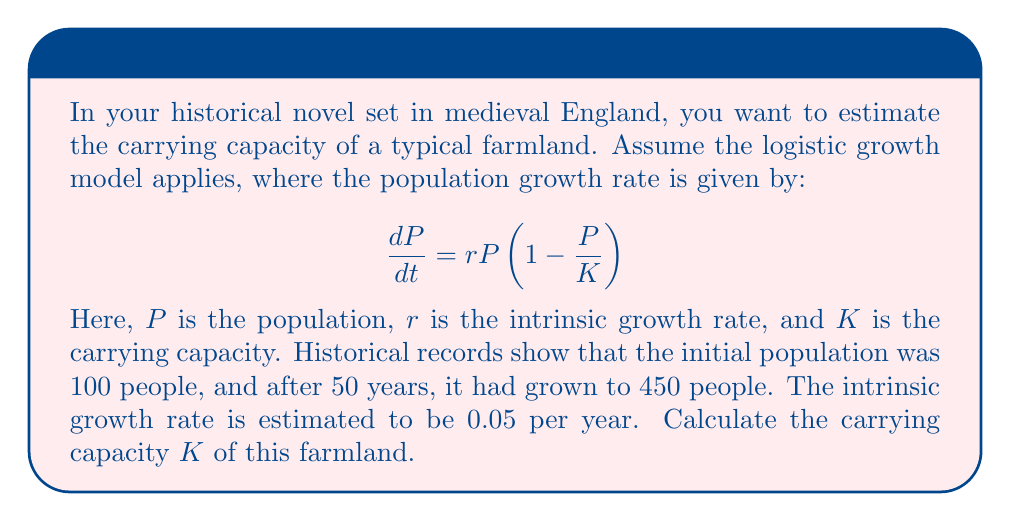Provide a solution to this math problem. To solve this problem, we need to use the solution to the logistic growth equation:

$$P(t) = \frac{K}{1 + (\frac{K}{P_0} - 1)e^{-rt}}$$

Where $P(t)$ is the population at time $t$, $P_0$ is the initial population, $r$ is the intrinsic growth rate, and $K$ is the carrying capacity.

Given:
- $P_0 = 100$ (initial population)
- $P(50) = 450$ (population after 50 years)
- $r = 0.05$ per year
- $t = 50$ years

Let's substitute these values into the equation:

$$450 = \frac{K}{1 + (\frac{K}{100} - 1)e^{-0.05 \cdot 50}}$$

Now, we need to solve this equation for $K$. This is a complex equation, so we'll use algebraic manipulation:

1) Multiply both sides by the denominator:
   $$450(1 + (\frac{K}{100} - 1)e^{-2.5}) = K$$

2) Expand the brackets:
   $$450 + 450(\frac{K}{100} - 1)e^{-2.5} = K$$

3) Simplify:
   $$450 + 4.5Ke^{-2.5} - 450e^{-2.5} = K$$

4) Rearrange terms:
   $$450 - 450e^{-2.5} = K - 4.5Ke^{-2.5}$$

5) Factor out K on the right side:
   $$450 - 450e^{-2.5} = K(1 - 4.5e^{-2.5})$$

6) Solve for K:
   $$K = \frac{450 - 450e^{-2.5}}{1 - 4.5e^{-2.5}}$$

7) Calculate the value (using a calculator):
   $$K \approx 500.8$$

Therefore, the carrying capacity of the farmland is approximately 501 people (rounding to the nearest whole number).
Answer: The carrying capacity $K$ of the farmland is approximately 501 people. 